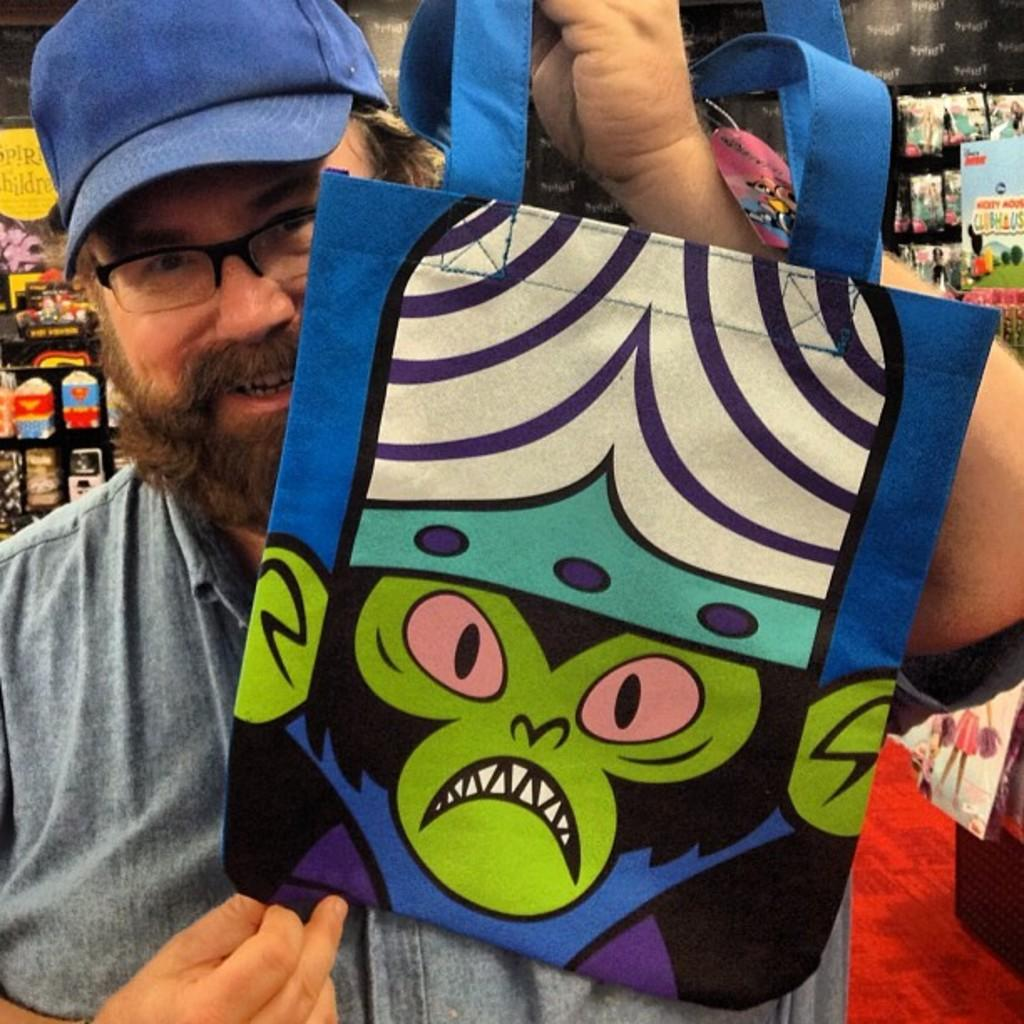What is present in the image? There is a person in the image. Can you describe the person's attire? The person is wearing clothes, a cap, and spectacles. What is the person holding in the image? The person is holding a bag with his hand. What type of alley can be seen behind the person in the image? There is no alley present in the image; it only features a person wearing clothes, a cap, and spectacles, holding a bag. 